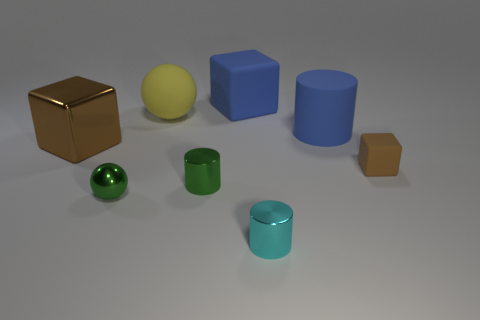Is there a cyan cube?
Your answer should be very brief. No. Is the brown thing left of the tiny brown thing made of the same material as the big yellow sphere?
Offer a terse response. No. What size is the other metal block that is the same color as the small cube?
Ensure brevity in your answer.  Large. What number of blue metal balls have the same size as the blue matte block?
Offer a very short reply. 0. Are there the same number of small green metallic balls that are behind the blue cylinder and big blue cylinders?
Make the answer very short. No. How many large rubber things are both in front of the yellow ball and to the left of the green cylinder?
Offer a terse response. 0. The yellow object that is made of the same material as the big blue cube is what size?
Your response must be concise. Large. What number of green shiny things are the same shape as the yellow rubber thing?
Provide a succinct answer. 1. Are there more big matte objects that are behind the big matte ball than large cyan matte cubes?
Offer a terse response. Yes. The thing that is both behind the big brown object and to the right of the blue cube has what shape?
Provide a succinct answer. Cylinder. 